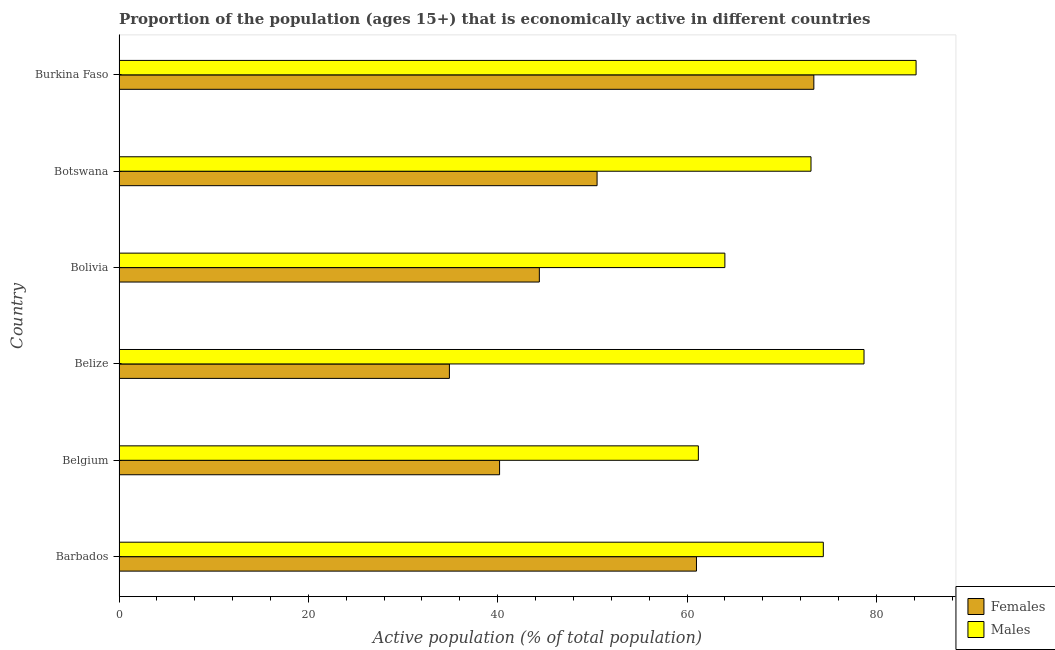How many different coloured bars are there?
Offer a very short reply. 2. How many groups of bars are there?
Your answer should be compact. 6. How many bars are there on the 5th tick from the bottom?
Offer a very short reply. 2. What is the label of the 2nd group of bars from the top?
Your answer should be compact. Botswana. In how many cases, is the number of bars for a given country not equal to the number of legend labels?
Provide a succinct answer. 0. Across all countries, what is the maximum percentage of economically active male population?
Give a very brief answer. 84.2. Across all countries, what is the minimum percentage of economically active male population?
Make the answer very short. 61.2. In which country was the percentage of economically active male population maximum?
Keep it short and to the point. Burkina Faso. In which country was the percentage of economically active female population minimum?
Your answer should be compact. Belize. What is the total percentage of economically active male population in the graph?
Offer a terse response. 435.6. What is the difference between the percentage of economically active male population in Bolivia and the percentage of economically active female population in Belgium?
Provide a succinct answer. 23.8. What is the average percentage of economically active female population per country?
Your answer should be compact. 50.73. What is the difference between the percentage of economically active male population and percentage of economically active female population in Barbados?
Provide a succinct answer. 13.4. What is the ratio of the percentage of economically active male population in Belize to that in Burkina Faso?
Provide a succinct answer. 0.94. Is the percentage of economically active male population in Bolivia less than that in Burkina Faso?
Your response must be concise. Yes. Is the difference between the percentage of economically active male population in Bolivia and Botswana greater than the difference between the percentage of economically active female population in Bolivia and Botswana?
Ensure brevity in your answer.  No. What is the difference between the highest and the second highest percentage of economically active male population?
Your answer should be very brief. 5.5. In how many countries, is the percentage of economically active female population greater than the average percentage of economically active female population taken over all countries?
Your answer should be compact. 2. Is the sum of the percentage of economically active male population in Belize and Botswana greater than the maximum percentage of economically active female population across all countries?
Ensure brevity in your answer.  Yes. What does the 1st bar from the top in Barbados represents?
Keep it short and to the point. Males. What does the 2nd bar from the bottom in Belize represents?
Your answer should be very brief. Males. How many bars are there?
Provide a short and direct response. 12. Does the graph contain grids?
Your answer should be very brief. No. Where does the legend appear in the graph?
Make the answer very short. Bottom right. What is the title of the graph?
Give a very brief answer. Proportion of the population (ages 15+) that is economically active in different countries. What is the label or title of the X-axis?
Keep it short and to the point. Active population (% of total population). What is the label or title of the Y-axis?
Your response must be concise. Country. What is the Active population (% of total population) in Females in Barbados?
Provide a short and direct response. 61. What is the Active population (% of total population) in Males in Barbados?
Keep it short and to the point. 74.4. What is the Active population (% of total population) in Females in Belgium?
Keep it short and to the point. 40.2. What is the Active population (% of total population) of Males in Belgium?
Give a very brief answer. 61.2. What is the Active population (% of total population) of Females in Belize?
Offer a terse response. 34.9. What is the Active population (% of total population) in Males in Belize?
Keep it short and to the point. 78.7. What is the Active population (% of total population) of Females in Bolivia?
Your response must be concise. 44.4. What is the Active population (% of total population) of Females in Botswana?
Provide a succinct answer. 50.5. What is the Active population (% of total population) in Males in Botswana?
Your answer should be very brief. 73.1. What is the Active population (% of total population) of Females in Burkina Faso?
Ensure brevity in your answer.  73.4. What is the Active population (% of total population) in Males in Burkina Faso?
Offer a terse response. 84.2. Across all countries, what is the maximum Active population (% of total population) of Females?
Make the answer very short. 73.4. Across all countries, what is the maximum Active population (% of total population) in Males?
Provide a short and direct response. 84.2. Across all countries, what is the minimum Active population (% of total population) of Females?
Offer a very short reply. 34.9. Across all countries, what is the minimum Active population (% of total population) of Males?
Ensure brevity in your answer.  61.2. What is the total Active population (% of total population) of Females in the graph?
Make the answer very short. 304.4. What is the total Active population (% of total population) in Males in the graph?
Your response must be concise. 435.6. What is the difference between the Active population (% of total population) in Females in Barbados and that in Belgium?
Ensure brevity in your answer.  20.8. What is the difference between the Active population (% of total population) of Males in Barbados and that in Belgium?
Provide a short and direct response. 13.2. What is the difference between the Active population (% of total population) of Females in Barbados and that in Belize?
Provide a short and direct response. 26.1. What is the difference between the Active population (% of total population) of Males in Barbados and that in Belize?
Your answer should be very brief. -4.3. What is the difference between the Active population (% of total population) in Females in Barbados and that in Bolivia?
Provide a short and direct response. 16.6. What is the difference between the Active population (% of total population) in Males in Barbados and that in Bolivia?
Offer a very short reply. 10.4. What is the difference between the Active population (% of total population) in Females in Barbados and that in Botswana?
Your answer should be compact. 10.5. What is the difference between the Active population (% of total population) in Males in Barbados and that in Botswana?
Your response must be concise. 1.3. What is the difference between the Active population (% of total population) of Females in Barbados and that in Burkina Faso?
Your answer should be very brief. -12.4. What is the difference between the Active population (% of total population) of Females in Belgium and that in Belize?
Your answer should be compact. 5.3. What is the difference between the Active population (% of total population) in Males in Belgium and that in Belize?
Give a very brief answer. -17.5. What is the difference between the Active population (% of total population) of Females in Belgium and that in Bolivia?
Provide a short and direct response. -4.2. What is the difference between the Active population (% of total population) of Males in Belgium and that in Bolivia?
Give a very brief answer. -2.8. What is the difference between the Active population (% of total population) in Males in Belgium and that in Botswana?
Ensure brevity in your answer.  -11.9. What is the difference between the Active population (% of total population) in Females in Belgium and that in Burkina Faso?
Ensure brevity in your answer.  -33.2. What is the difference between the Active population (% of total population) of Females in Belize and that in Botswana?
Your answer should be compact. -15.6. What is the difference between the Active population (% of total population) in Males in Belize and that in Botswana?
Ensure brevity in your answer.  5.6. What is the difference between the Active population (% of total population) of Females in Belize and that in Burkina Faso?
Ensure brevity in your answer.  -38.5. What is the difference between the Active population (% of total population) in Males in Bolivia and that in Burkina Faso?
Offer a terse response. -20.2. What is the difference between the Active population (% of total population) in Females in Botswana and that in Burkina Faso?
Your answer should be compact. -22.9. What is the difference between the Active population (% of total population) in Females in Barbados and the Active population (% of total population) in Males in Belize?
Your answer should be compact. -17.7. What is the difference between the Active population (% of total population) of Females in Barbados and the Active population (% of total population) of Males in Bolivia?
Provide a succinct answer. -3. What is the difference between the Active population (% of total population) in Females in Barbados and the Active population (% of total population) in Males in Botswana?
Make the answer very short. -12.1. What is the difference between the Active population (% of total population) in Females in Barbados and the Active population (% of total population) in Males in Burkina Faso?
Give a very brief answer. -23.2. What is the difference between the Active population (% of total population) of Females in Belgium and the Active population (% of total population) of Males in Belize?
Give a very brief answer. -38.5. What is the difference between the Active population (% of total population) in Females in Belgium and the Active population (% of total population) in Males in Bolivia?
Make the answer very short. -23.8. What is the difference between the Active population (% of total population) of Females in Belgium and the Active population (% of total population) of Males in Botswana?
Keep it short and to the point. -32.9. What is the difference between the Active population (% of total population) of Females in Belgium and the Active population (% of total population) of Males in Burkina Faso?
Give a very brief answer. -44. What is the difference between the Active population (% of total population) in Females in Belize and the Active population (% of total population) in Males in Bolivia?
Your response must be concise. -29.1. What is the difference between the Active population (% of total population) of Females in Belize and the Active population (% of total population) of Males in Botswana?
Provide a short and direct response. -38.2. What is the difference between the Active population (% of total population) in Females in Belize and the Active population (% of total population) in Males in Burkina Faso?
Ensure brevity in your answer.  -49.3. What is the difference between the Active population (% of total population) in Females in Bolivia and the Active population (% of total population) in Males in Botswana?
Offer a terse response. -28.7. What is the difference between the Active population (% of total population) in Females in Bolivia and the Active population (% of total population) in Males in Burkina Faso?
Offer a very short reply. -39.8. What is the difference between the Active population (% of total population) in Females in Botswana and the Active population (% of total population) in Males in Burkina Faso?
Keep it short and to the point. -33.7. What is the average Active population (% of total population) in Females per country?
Keep it short and to the point. 50.73. What is the average Active population (% of total population) in Males per country?
Your response must be concise. 72.6. What is the difference between the Active population (% of total population) in Females and Active population (% of total population) in Males in Belize?
Provide a succinct answer. -43.8. What is the difference between the Active population (% of total population) in Females and Active population (% of total population) in Males in Bolivia?
Provide a short and direct response. -19.6. What is the difference between the Active population (% of total population) in Females and Active population (% of total population) in Males in Botswana?
Keep it short and to the point. -22.6. What is the difference between the Active population (% of total population) in Females and Active population (% of total population) in Males in Burkina Faso?
Give a very brief answer. -10.8. What is the ratio of the Active population (% of total population) in Females in Barbados to that in Belgium?
Give a very brief answer. 1.52. What is the ratio of the Active population (% of total population) of Males in Barbados to that in Belgium?
Keep it short and to the point. 1.22. What is the ratio of the Active population (% of total population) of Females in Barbados to that in Belize?
Provide a succinct answer. 1.75. What is the ratio of the Active population (% of total population) of Males in Barbados to that in Belize?
Ensure brevity in your answer.  0.95. What is the ratio of the Active population (% of total population) of Females in Barbados to that in Bolivia?
Provide a succinct answer. 1.37. What is the ratio of the Active population (% of total population) in Males in Barbados to that in Bolivia?
Offer a very short reply. 1.16. What is the ratio of the Active population (% of total population) of Females in Barbados to that in Botswana?
Your answer should be compact. 1.21. What is the ratio of the Active population (% of total population) in Males in Barbados to that in Botswana?
Offer a very short reply. 1.02. What is the ratio of the Active population (% of total population) in Females in Barbados to that in Burkina Faso?
Keep it short and to the point. 0.83. What is the ratio of the Active population (% of total population) in Males in Barbados to that in Burkina Faso?
Your answer should be very brief. 0.88. What is the ratio of the Active population (% of total population) of Females in Belgium to that in Belize?
Keep it short and to the point. 1.15. What is the ratio of the Active population (% of total population) in Males in Belgium to that in Belize?
Provide a short and direct response. 0.78. What is the ratio of the Active population (% of total population) in Females in Belgium to that in Bolivia?
Offer a very short reply. 0.91. What is the ratio of the Active population (% of total population) in Males in Belgium to that in Bolivia?
Keep it short and to the point. 0.96. What is the ratio of the Active population (% of total population) of Females in Belgium to that in Botswana?
Your response must be concise. 0.8. What is the ratio of the Active population (% of total population) in Males in Belgium to that in Botswana?
Provide a short and direct response. 0.84. What is the ratio of the Active population (% of total population) in Females in Belgium to that in Burkina Faso?
Provide a short and direct response. 0.55. What is the ratio of the Active population (% of total population) in Males in Belgium to that in Burkina Faso?
Ensure brevity in your answer.  0.73. What is the ratio of the Active population (% of total population) of Females in Belize to that in Bolivia?
Your answer should be compact. 0.79. What is the ratio of the Active population (% of total population) in Males in Belize to that in Bolivia?
Offer a terse response. 1.23. What is the ratio of the Active population (% of total population) in Females in Belize to that in Botswana?
Provide a short and direct response. 0.69. What is the ratio of the Active population (% of total population) of Males in Belize to that in Botswana?
Provide a succinct answer. 1.08. What is the ratio of the Active population (% of total population) in Females in Belize to that in Burkina Faso?
Offer a terse response. 0.48. What is the ratio of the Active population (% of total population) of Males in Belize to that in Burkina Faso?
Offer a very short reply. 0.93. What is the ratio of the Active population (% of total population) of Females in Bolivia to that in Botswana?
Provide a short and direct response. 0.88. What is the ratio of the Active population (% of total population) of Males in Bolivia to that in Botswana?
Your response must be concise. 0.88. What is the ratio of the Active population (% of total population) of Females in Bolivia to that in Burkina Faso?
Make the answer very short. 0.6. What is the ratio of the Active population (% of total population) of Males in Bolivia to that in Burkina Faso?
Provide a short and direct response. 0.76. What is the ratio of the Active population (% of total population) of Females in Botswana to that in Burkina Faso?
Offer a very short reply. 0.69. What is the ratio of the Active population (% of total population) of Males in Botswana to that in Burkina Faso?
Give a very brief answer. 0.87. What is the difference between the highest and the lowest Active population (% of total population) in Females?
Keep it short and to the point. 38.5. 